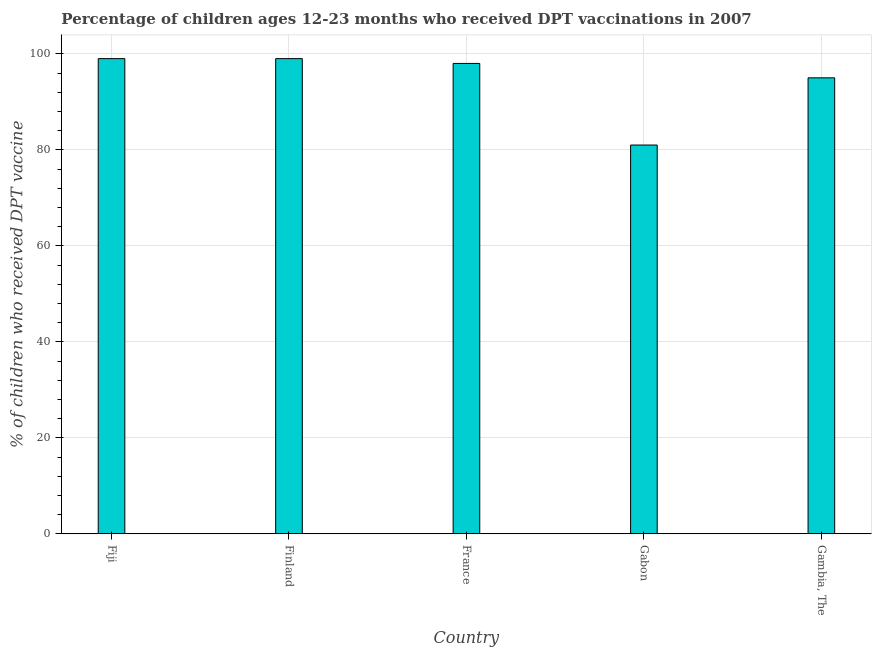Does the graph contain any zero values?
Offer a terse response. No. What is the title of the graph?
Provide a succinct answer. Percentage of children ages 12-23 months who received DPT vaccinations in 2007. What is the label or title of the X-axis?
Give a very brief answer. Country. What is the label or title of the Y-axis?
Make the answer very short. % of children who received DPT vaccine. Across all countries, what is the maximum percentage of children who received dpt vaccine?
Provide a short and direct response. 99. Across all countries, what is the minimum percentage of children who received dpt vaccine?
Offer a very short reply. 81. In which country was the percentage of children who received dpt vaccine maximum?
Your answer should be very brief. Fiji. In which country was the percentage of children who received dpt vaccine minimum?
Give a very brief answer. Gabon. What is the sum of the percentage of children who received dpt vaccine?
Offer a very short reply. 472. What is the difference between the percentage of children who received dpt vaccine in Finland and Gabon?
Your answer should be compact. 18. What is the average percentage of children who received dpt vaccine per country?
Offer a very short reply. 94.4. What is the median percentage of children who received dpt vaccine?
Ensure brevity in your answer.  98. What is the ratio of the percentage of children who received dpt vaccine in Finland to that in Gabon?
Your answer should be compact. 1.22. Is the difference between the percentage of children who received dpt vaccine in Finland and Gabon greater than the difference between any two countries?
Offer a terse response. Yes. What is the difference between the highest and the lowest percentage of children who received dpt vaccine?
Your answer should be very brief. 18. How many bars are there?
Your answer should be compact. 5. How many countries are there in the graph?
Your answer should be very brief. 5. Are the values on the major ticks of Y-axis written in scientific E-notation?
Keep it short and to the point. No. What is the % of children who received DPT vaccine in France?
Keep it short and to the point. 98. What is the % of children who received DPT vaccine in Gabon?
Give a very brief answer. 81. What is the difference between the % of children who received DPT vaccine in Fiji and Gabon?
Keep it short and to the point. 18. What is the difference between the % of children who received DPT vaccine in Fiji and Gambia, The?
Offer a very short reply. 4. What is the difference between the % of children who received DPT vaccine in Finland and France?
Your answer should be very brief. 1. What is the difference between the % of children who received DPT vaccine in France and Gabon?
Give a very brief answer. 17. What is the difference between the % of children who received DPT vaccine in France and Gambia, The?
Offer a very short reply. 3. What is the ratio of the % of children who received DPT vaccine in Fiji to that in France?
Keep it short and to the point. 1.01. What is the ratio of the % of children who received DPT vaccine in Fiji to that in Gabon?
Provide a short and direct response. 1.22. What is the ratio of the % of children who received DPT vaccine in Fiji to that in Gambia, The?
Provide a short and direct response. 1.04. What is the ratio of the % of children who received DPT vaccine in Finland to that in Gabon?
Offer a very short reply. 1.22. What is the ratio of the % of children who received DPT vaccine in Finland to that in Gambia, The?
Offer a terse response. 1.04. What is the ratio of the % of children who received DPT vaccine in France to that in Gabon?
Offer a terse response. 1.21. What is the ratio of the % of children who received DPT vaccine in France to that in Gambia, The?
Provide a short and direct response. 1.03. What is the ratio of the % of children who received DPT vaccine in Gabon to that in Gambia, The?
Keep it short and to the point. 0.85. 